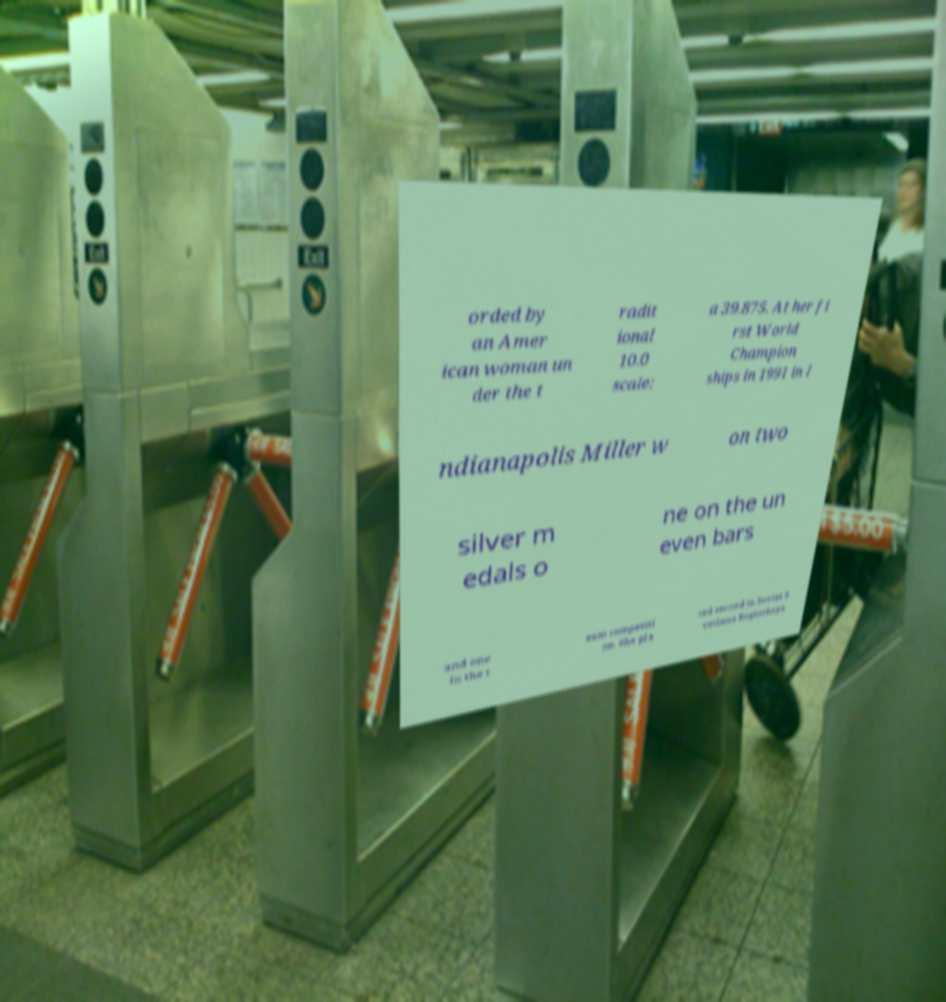Could you extract and type out the text from this image? orded by an Amer ican woman un der the t radit ional 10.0 scale: a 39.875. At her fi rst World Champion ships in 1991 in I ndianapolis Miller w on two silver m edals o ne on the un even bars and one in the t eam competiti on. She pla ced second to Soviet S vetlana Boginskaya 